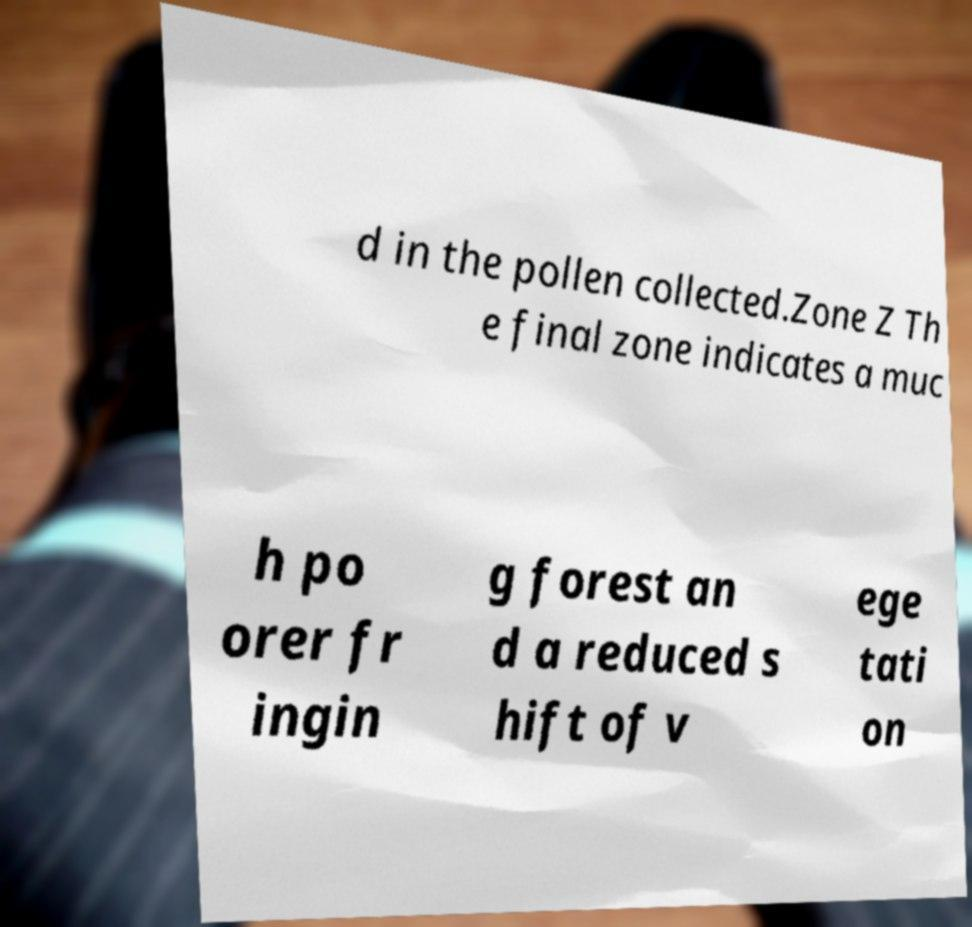Can you read and provide the text displayed in the image?This photo seems to have some interesting text. Can you extract and type it out for me? d in the pollen collected.Zone Z Th e final zone indicates a muc h po orer fr ingin g forest an d a reduced s hift of v ege tati on 